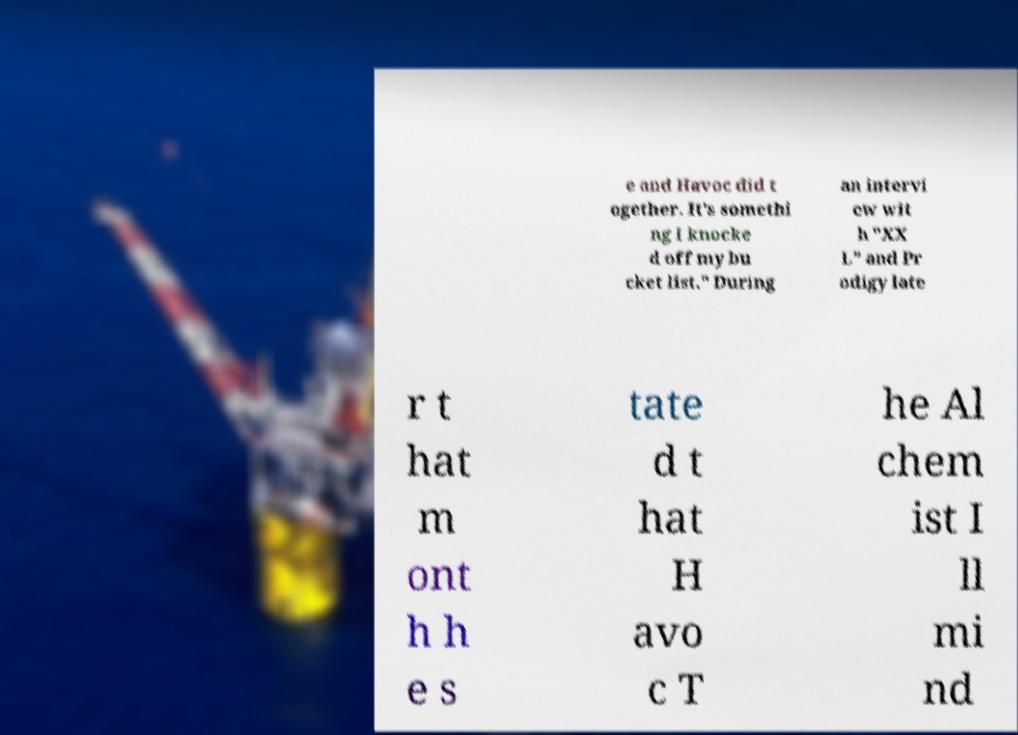There's text embedded in this image that I need extracted. Can you transcribe it verbatim? e and Havoc did t ogether. It's somethi ng I knocke d off my bu cket list." During an intervi ew wit h "XX L" and Pr odigy late r t hat m ont h h e s tate d t hat H avo c T he Al chem ist I ll mi nd 